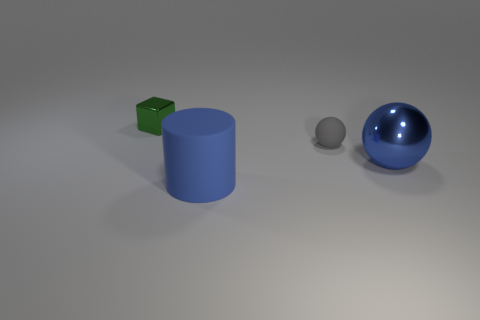Subtract all blocks. How many objects are left? 3 Subtract all blue spheres. How many spheres are left? 1 Subtract 0 brown cubes. How many objects are left? 4 Subtract 1 cylinders. How many cylinders are left? 0 Subtract all yellow spheres. Subtract all blue cubes. How many spheres are left? 2 Subtract all brown balls. How many purple cubes are left? 0 Subtract all big blue matte things. Subtract all small matte objects. How many objects are left? 2 Add 4 big things. How many big things are left? 6 Add 1 blue balls. How many blue balls exist? 2 Add 1 tiny objects. How many objects exist? 5 